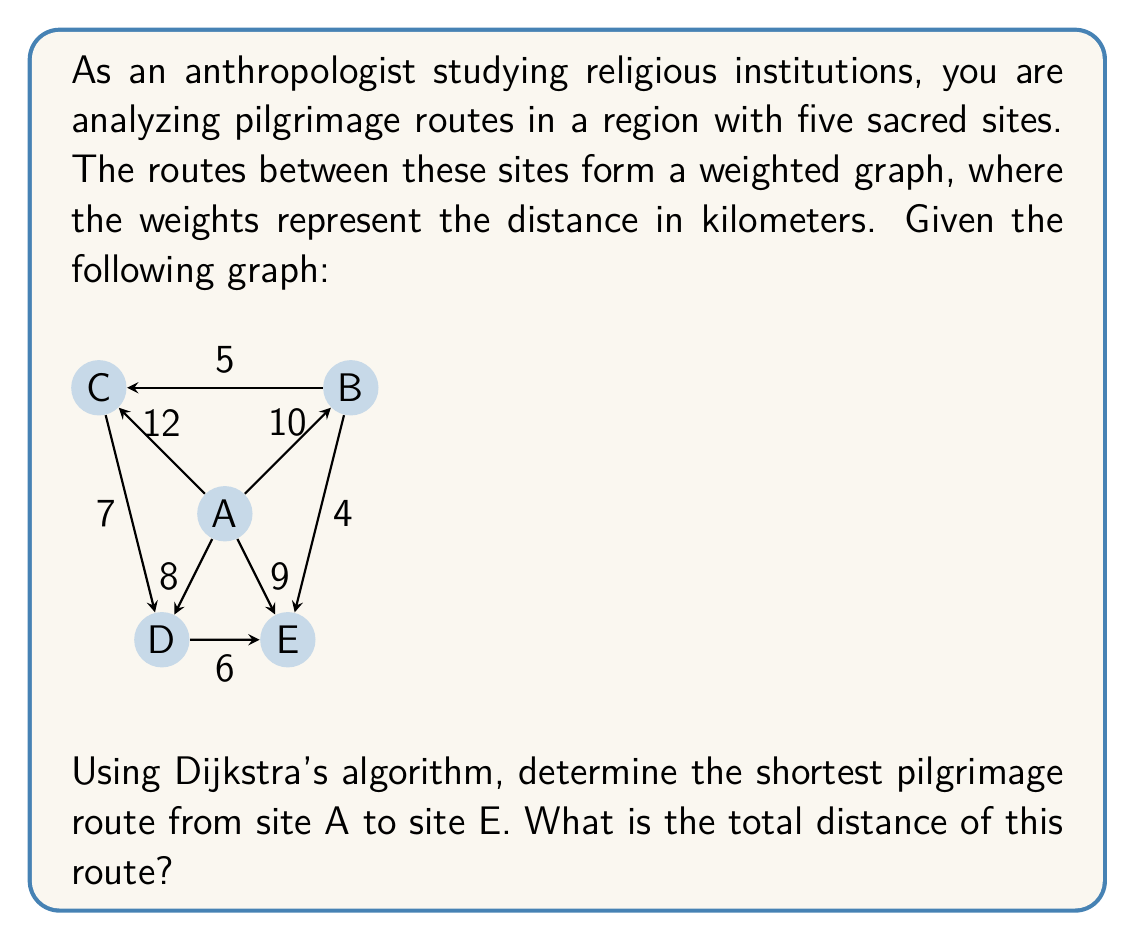Can you solve this math problem? To solve this problem, we'll apply Dijkstra's algorithm to find the shortest path from site A to site E. Here's a step-by-step explanation:

1) Initialize:
   - Set distance to A as 0, and all others as infinity.
   - Set all nodes as unvisited.
   - Set A as the current node.

2) For the current node, consider all unvisited neighbors and calculate their tentative distances:
   - A to B: 10 km
   - A to C: 12 km
   - A to D: 8 km
   - A to E: 9 km

3) Mark A as visited. The tentative distances are:
   A: 0, B: 10, C: 12, D: 8, E: 9

4) Select the unvisited node with the smallest tentative distance (D) as the new current node.

5) For D, calculate distances to unvisited neighbors:
   - D to C: 8 + 7 = 15 km (greater than current C, so no update)
   - D to E: 8 + 6 = 14 km (greater than current E, so no update)

6) Mark D as visited. Tentative distances remain:
   A: 0, B: 10, C: 12, D: 8, E: 9

7) Select E as the new current node (smallest tentative distance among unvisited).

8) All neighbors of E are visited, so mark E as visited.

9) The algorithm terminates as we've reached our destination E.

The shortest path from A to E is directly from A to E, with a total distance of 9 km.
Answer: The shortest pilgrimage route from site A to site E is the direct path A $\rightarrow$ E, with a total distance of 9 km. 